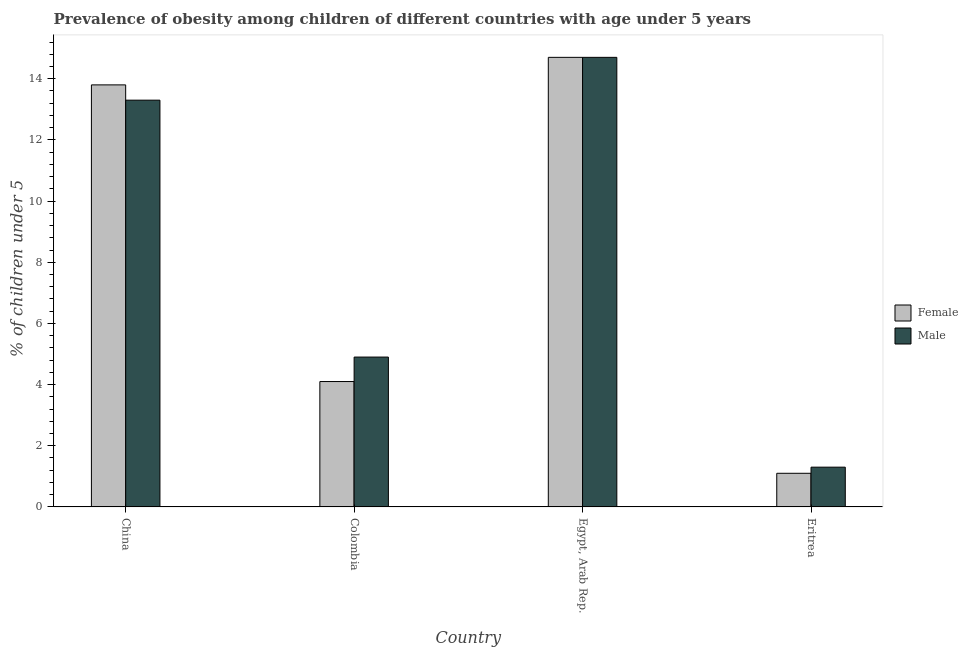How many different coloured bars are there?
Ensure brevity in your answer.  2. Are the number of bars per tick equal to the number of legend labels?
Your answer should be compact. Yes. Are the number of bars on each tick of the X-axis equal?
Offer a terse response. Yes. How many bars are there on the 4th tick from the left?
Offer a very short reply. 2. In how many cases, is the number of bars for a given country not equal to the number of legend labels?
Offer a terse response. 0. What is the percentage of obese female children in Colombia?
Provide a short and direct response. 4.1. Across all countries, what is the maximum percentage of obese female children?
Your response must be concise. 14.7. Across all countries, what is the minimum percentage of obese female children?
Keep it short and to the point. 1.1. In which country was the percentage of obese male children maximum?
Provide a short and direct response. Egypt, Arab Rep. In which country was the percentage of obese male children minimum?
Your answer should be compact. Eritrea. What is the total percentage of obese female children in the graph?
Make the answer very short. 33.7. What is the difference between the percentage of obese male children in Colombia and that in Egypt, Arab Rep.?
Offer a very short reply. -9.8. What is the difference between the percentage of obese female children in China and the percentage of obese male children in Colombia?
Offer a very short reply. 8.9. What is the average percentage of obese male children per country?
Your response must be concise. 8.55. What is the difference between the percentage of obese male children and percentage of obese female children in China?
Offer a terse response. -0.5. In how many countries, is the percentage of obese male children greater than 10 %?
Give a very brief answer. 2. What is the ratio of the percentage of obese male children in China to that in Egypt, Arab Rep.?
Your answer should be compact. 0.9. Is the percentage of obese male children in China less than that in Colombia?
Make the answer very short. No. Is the difference between the percentage of obese male children in China and Eritrea greater than the difference between the percentage of obese female children in China and Eritrea?
Your answer should be very brief. No. What is the difference between the highest and the second highest percentage of obese male children?
Keep it short and to the point. 1.4. What is the difference between the highest and the lowest percentage of obese male children?
Your answer should be very brief. 13.4. In how many countries, is the percentage of obese female children greater than the average percentage of obese female children taken over all countries?
Your answer should be very brief. 2. What does the 2nd bar from the left in Egypt, Arab Rep. represents?
Provide a short and direct response. Male. What does the 1st bar from the right in Eritrea represents?
Provide a succinct answer. Male. What is the difference between two consecutive major ticks on the Y-axis?
Provide a short and direct response. 2. Does the graph contain any zero values?
Offer a very short reply. No. Does the graph contain grids?
Keep it short and to the point. No. Where does the legend appear in the graph?
Keep it short and to the point. Center right. How many legend labels are there?
Provide a short and direct response. 2. What is the title of the graph?
Give a very brief answer. Prevalence of obesity among children of different countries with age under 5 years. What is the label or title of the X-axis?
Give a very brief answer. Country. What is the label or title of the Y-axis?
Your answer should be very brief.  % of children under 5. What is the  % of children under 5 of Female in China?
Provide a short and direct response. 13.8. What is the  % of children under 5 in Male in China?
Ensure brevity in your answer.  13.3. What is the  % of children under 5 of Female in Colombia?
Give a very brief answer. 4.1. What is the  % of children under 5 of Male in Colombia?
Offer a terse response. 4.9. What is the  % of children under 5 in Female in Egypt, Arab Rep.?
Make the answer very short. 14.7. What is the  % of children under 5 in Male in Egypt, Arab Rep.?
Provide a succinct answer. 14.7. What is the  % of children under 5 in Female in Eritrea?
Make the answer very short. 1.1. What is the  % of children under 5 in Male in Eritrea?
Keep it short and to the point. 1.3. Across all countries, what is the maximum  % of children under 5 of Female?
Offer a terse response. 14.7. Across all countries, what is the maximum  % of children under 5 in Male?
Provide a short and direct response. 14.7. Across all countries, what is the minimum  % of children under 5 in Female?
Your answer should be compact. 1.1. Across all countries, what is the minimum  % of children under 5 of Male?
Offer a very short reply. 1.3. What is the total  % of children under 5 of Female in the graph?
Offer a very short reply. 33.7. What is the total  % of children under 5 in Male in the graph?
Ensure brevity in your answer.  34.2. What is the difference between the  % of children under 5 in Male in China and that in Egypt, Arab Rep.?
Keep it short and to the point. -1.4. What is the difference between the  % of children under 5 in Female in China and that in Eritrea?
Provide a short and direct response. 12.7. What is the difference between the  % of children under 5 of Male in China and that in Eritrea?
Provide a short and direct response. 12. What is the difference between the  % of children under 5 of Male in Colombia and that in Egypt, Arab Rep.?
Provide a succinct answer. -9.8. What is the difference between the  % of children under 5 in Female in Colombia and that in Eritrea?
Provide a succinct answer. 3. What is the difference between the  % of children under 5 in Male in Colombia and that in Eritrea?
Make the answer very short. 3.6. What is the difference between the  % of children under 5 of Female in China and the  % of children under 5 of Male in Colombia?
Keep it short and to the point. 8.9. What is the difference between the  % of children under 5 of Female in China and the  % of children under 5 of Male in Eritrea?
Your answer should be compact. 12.5. What is the difference between the  % of children under 5 in Female in Colombia and the  % of children under 5 in Male in Eritrea?
Keep it short and to the point. 2.8. What is the difference between the  % of children under 5 in Female in Egypt, Arab Rep. and the  % of children under 5 in Male in Eritrea?
Offer a terse response. 13.4. What is the average  % of children under 5 of Female per country?
Give a very brief answer. 8.43. What is the average  % of children under 5 of Male per country?
Provide a short and direct response. 8.55. What is the difference between the  % of children under 5 in Female and  % of children under 5 in Male in China?
Offer a terse response. 0.5. What is the ratio of the  % of children under 5 in Female in China to that in Colombia?
Offer a terse response. 3.37. What is the ratio of the  % of children under 5 in Male in China to that in Colombia?
Ensure brevity in your answer.  2.71. What is the ratio of the  % of children under 5 of Female in China to that in Egypt, Arab Rep.?
Offer a very short reply. 0.94. What is the ratio of the  % of children under 5 of Male in China to that in Egypt, Arab Rep.?
Provide a succinct answer. 0.9. What is the ratio of the  % of children under 5 in Female in China to that in Eritrea?
Provide a succinct answer. 12.55. What is the ratio of the  % of children under 5 of Male in China to that in Eritrea?
Give a very brief answer. 10.23. What is the ratio of the  % of children under 5 in Female in Colombia to that in Egypt, Arab Rep.?
Your answer should be very brief. 0.28. What is the ratio of the  % of children under 5 of Male in Colombia to that in Egypt, Arab Rep.?
Provide a succinct answer. 0.33. What is the ratio of the  % of children under 5 in Female in Colombia to that in Eritrea?
Your response must be concise. 3.73. What is the ratio of the  % of children under 5 of Male in Colombia to that in Eritrea?
Your answer should be very brief. 3.77. What is the ratio of the  % of children under 5 in Female in Egypt, Arab Rep. to that in Eritrea?
Your answer should be very brief. 13.36. What is the ratio of the  % of children under 5 of Male in Egypt, Arab Rep. to that in Eritrea?
Give a very brief answer. 11.31. What is the difference between the highest and the second highest  % of children under 5 of Male?
Make the answer very short. 1.4. What is the difference between the highest and the lowest  % of children under 5 of Female?
Keep it short and to the point. 13.6. 